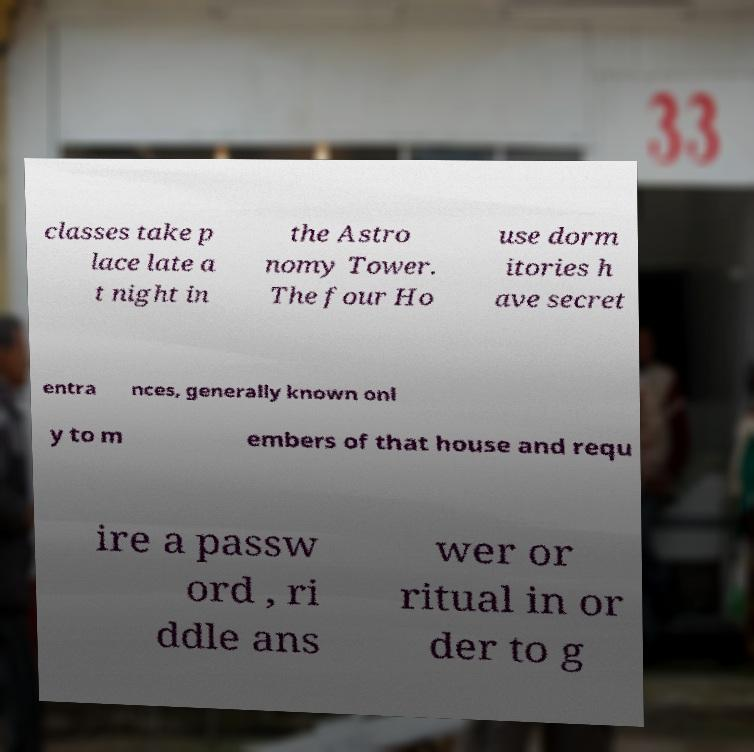Can you read and provide the text displayed in the image?This photo seems to have some interesting text. Can you extract and type it out for me? classes take p lace late a t night in the Astro nomy Tower. The four Ho use dorm itories h ave secret entra nces, generally known onl y to m embers of that house and requ ire a passw ord , ri ddle ans wer or ritual in or der to g 